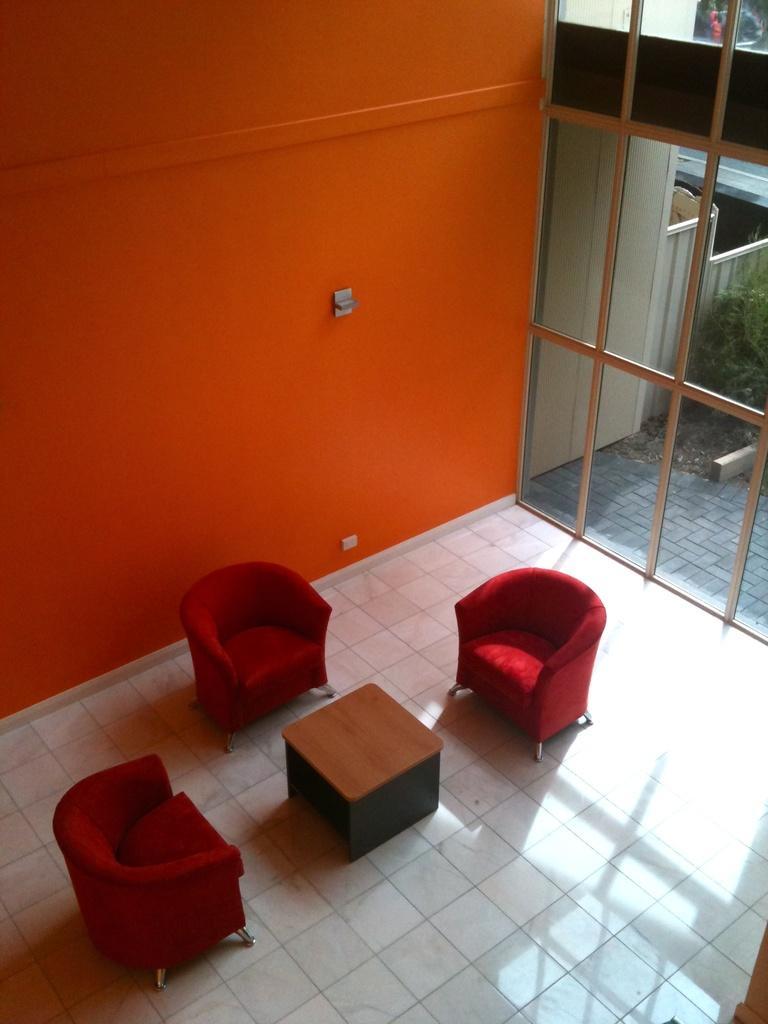Can you describe this image briefly? In the picture there is a room in which three chairs are present with table in front of it through the window we can see plants it is a glass window/. 